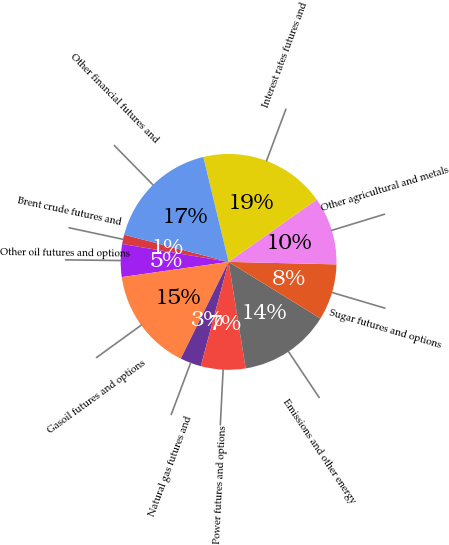Convert chart. <chart><loc_0><loc_0><loc_500><loc_500><pie_chart><fcel>Brent crude futures and<fcel>Other oil futures and options<fcel>Gasoil futures and options<fcel>Natural gas futures and<fcel>Power futures and options<fcel>Emissions and other energy<fcel>Sugar futures and options<fcel>Other agricultural and metals<fcel>Interest rates futures and<fcel>Other financial futures and<nl><fcel>1.4%<fcel>4.91%<fcel>15.44%<fcel>3.16%<fcel>6.67%<fcel>13.68%<fcel>8.42%<fcel>10.18%<fcel>18.95%<fcel>17.19%<nl></chart> 